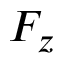Convert formula to latex. <formula><loc_0><loc_0><loc_500><loc_500>F _ { z }</formula> 